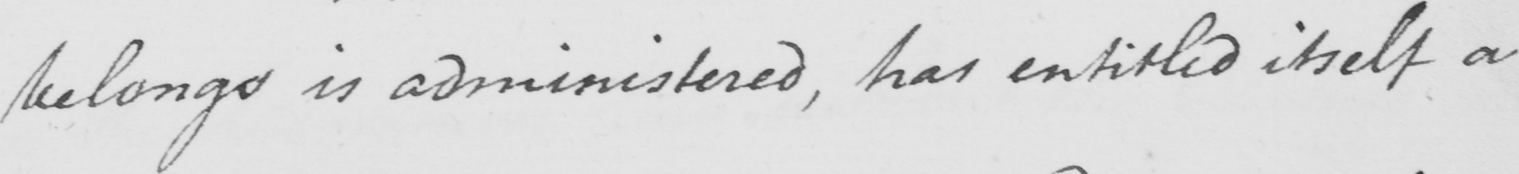Transcribe the text shown in this historical manuscript line. belongs is administered , has entitled itself a 